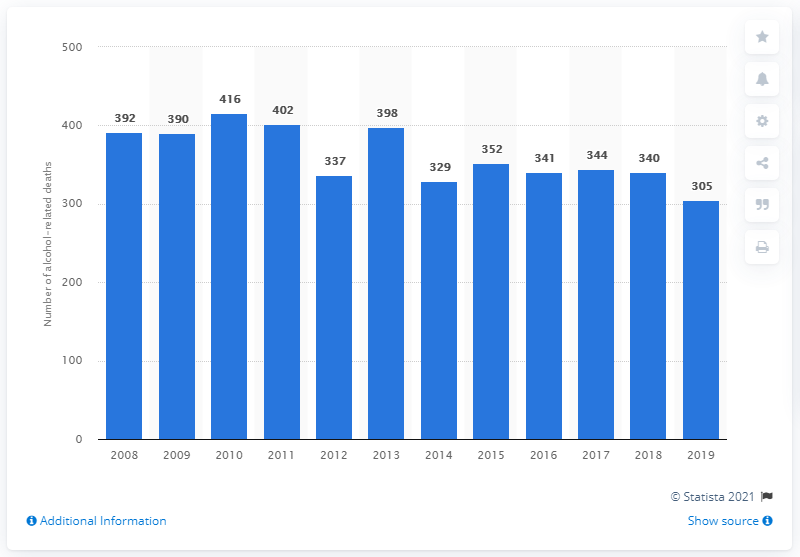Identify some key points in this picture. In 2019, there were 305 deaths in Norway that were related to alcohol. In 2010, a total of 416 individuals in Norway lost their lives due to alcohol-related causes. 